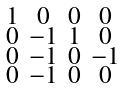Convert formula to latex. <formula><loc_0><loc_0><loc_500><loc_500>\begin{smallmatrix} 1 & 0 & 0 & 0 \\ 0 & - 1 & 1 & 0 \\ 0 & - 1 & 0 & - 1 \\ 0 & - 1 & 0 & 0 \end{smallmatrix}</formula> 